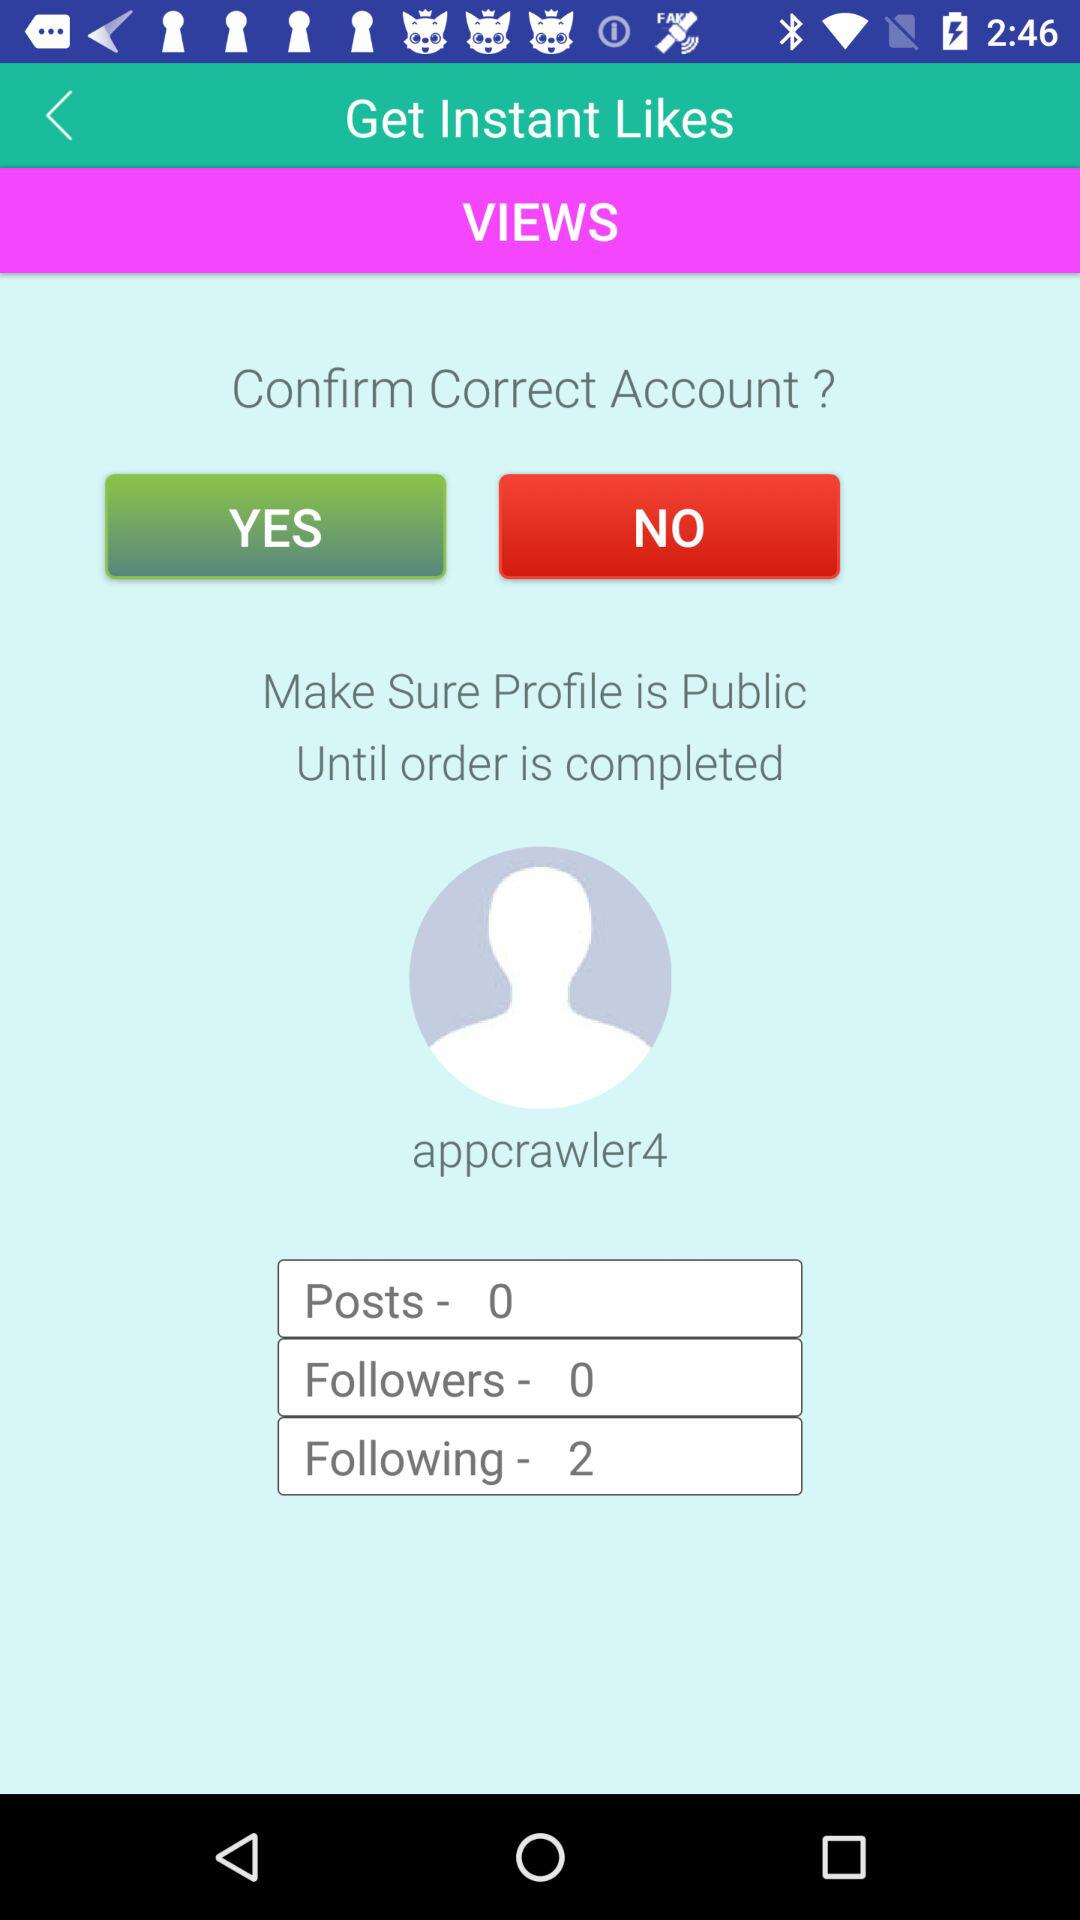How many people are followers of "appcrawler4"? There are 0 followers of "appcrawler4". 